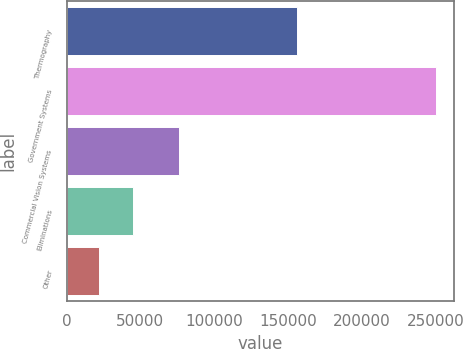Convert chart. <chart><loc_0><loc_0><loc_500><loc_500><bar_chart><fcel>Thermography<fcel>Government Systems<fcel>Commercial Vision Systems<fcel>Eliminations<fcel>Other<nl><fcel>155956<fcel>250295<fcel>76400<fcel>44819.6<fcel>21989<nl></chart> 